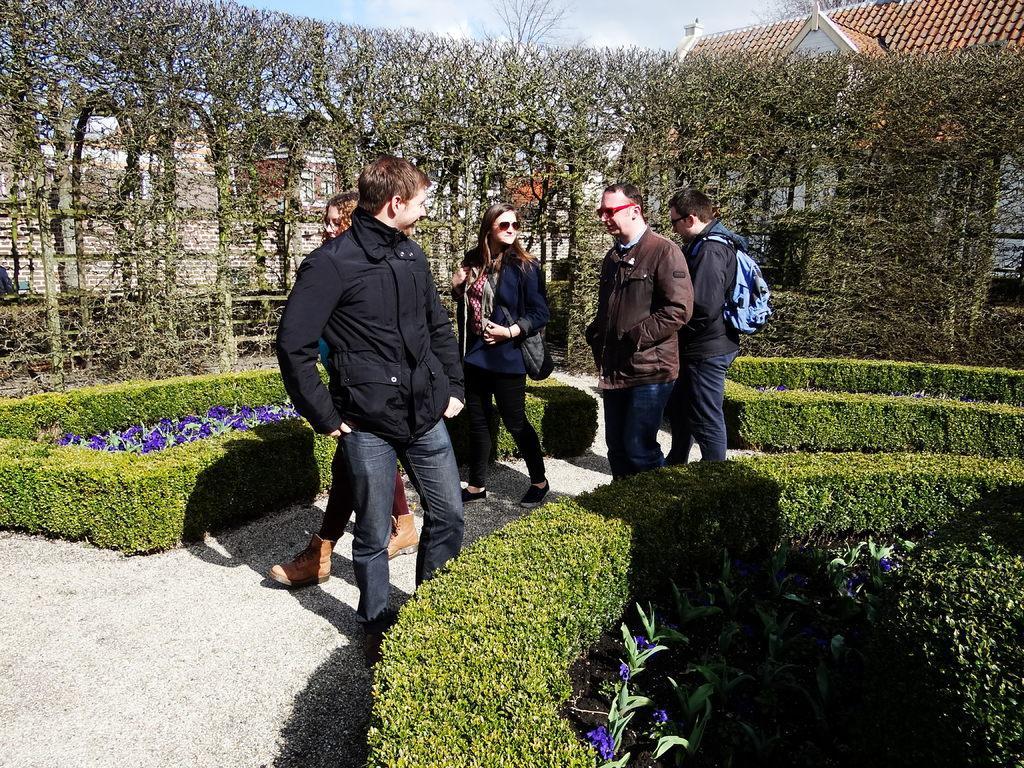Please provide a concise description of this image. In this image we can see a few people walking on the path. We can also see the plants, bushes and also the trees. In the background we can see the roof house and also the sky with some clouds. 